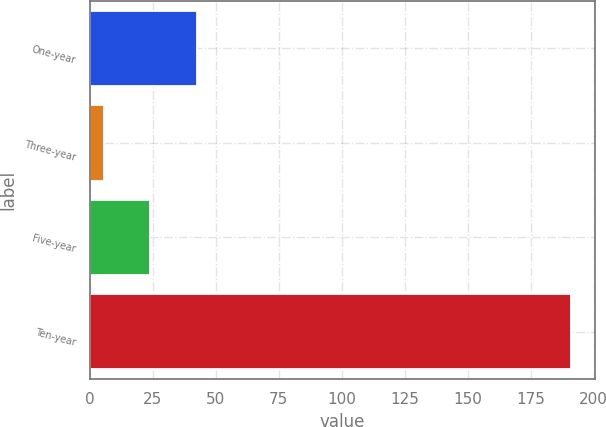Convert chart to OTSL. <chart><loc_0><loc_0><loc_500><loc_500><bar_chart><fcel>One-year<fcel>Three-year<fcel>Five-year<fcel>Ten-year<nl><fcel>42.54<fcel>5.4<fcel>23.97<fcel>191.1<nl></chart> 